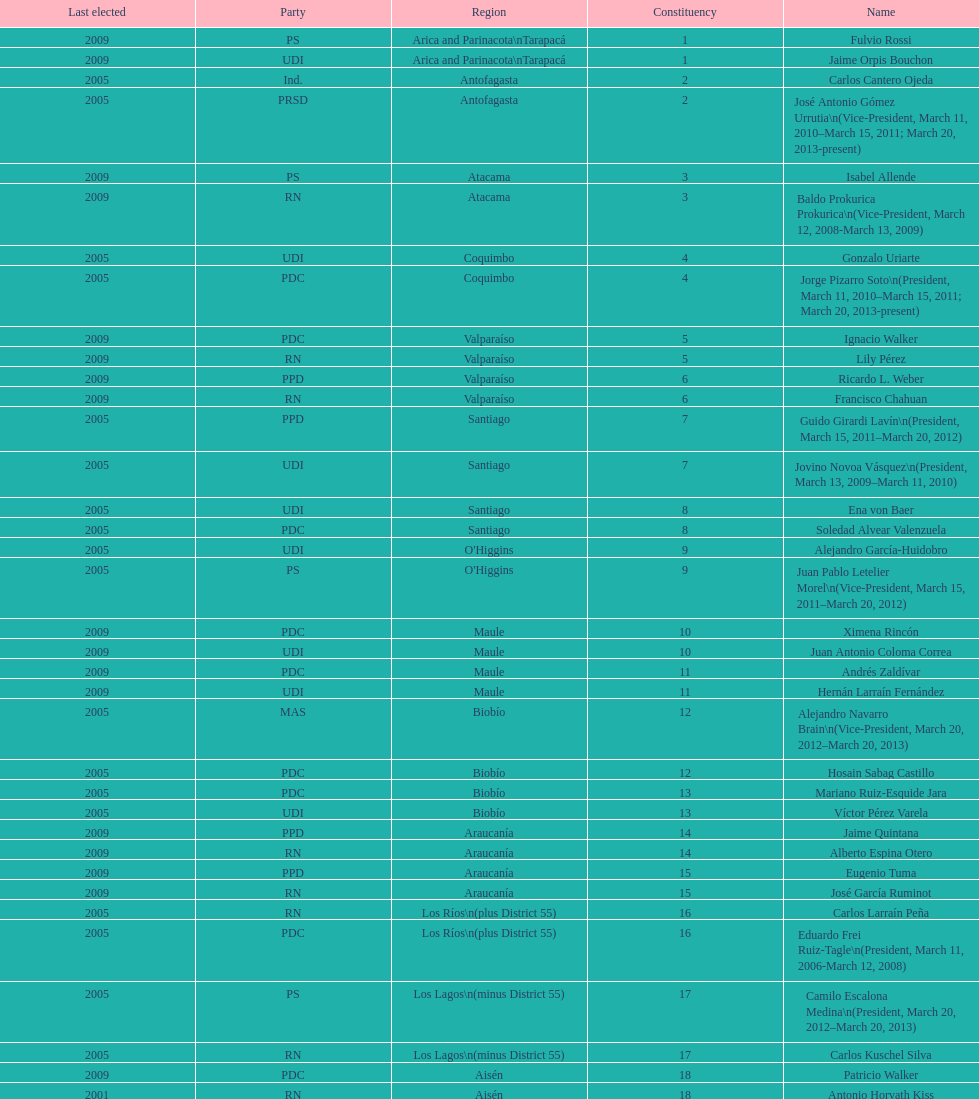How long was baldo prokurica prokurica vice-president? 1 year. 